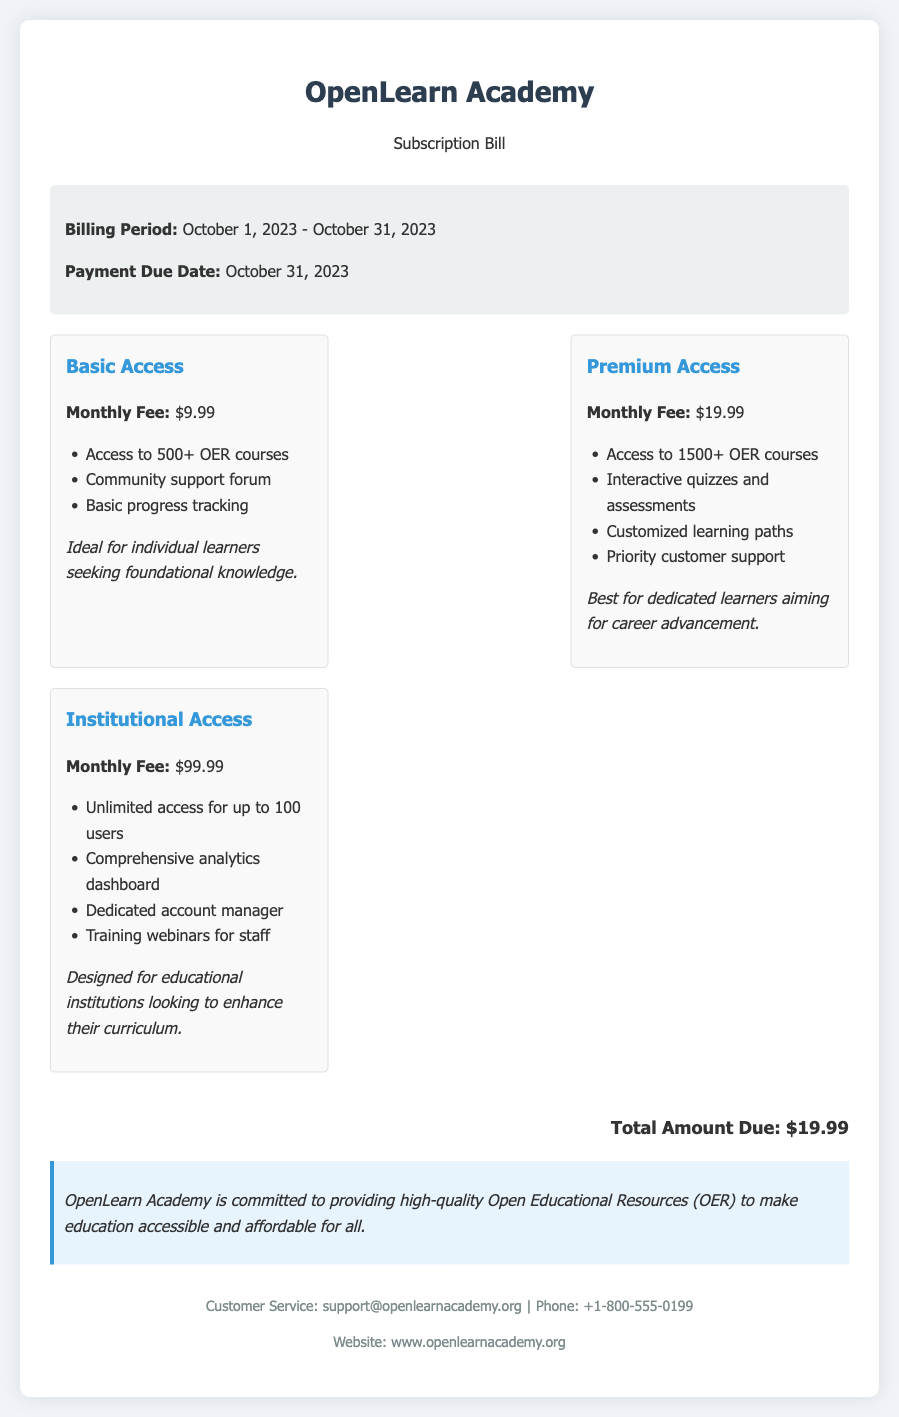What is the monthly fee for Basic Access? The monthly fee for Basic Access is stated in the document as $9.99.
Answer: $9.99 What is the total amount due for the current billing period? The total amount due is clearly mentioned in the document as $19.99.
Answer: $19.99 How many OER courses are available with Premium Access? The number of OER courses available with Premium Access is specified as 1500+.
Answer: 1500+ What is the billing period mentioned in the document? The billing period is identified as October 1, 2023 - October 31, 2023.
Answer: October 1, 2023 - October 31, 2023 Which subscription tier includes a dedicated account manager? The subscription tier that includes a dedicated account manager is Institutional Access.
Answer: Institutional Access How many users can access the Institutional Access tier? The document specifies that the Institutional Access tier allows unlimited access for up to 100 users.
Answer: 100 users What type of support is offered in Basic Access? Basic Access includes community support forum as part of its offerings.
Answer: Community support forum What is the purpose of the OER note at the bottom of the document? The OER note emphasizes OpenLearn Academy's commitment to making education accessible and affordable through OER.
Answer: Making education accessible and affordable What is the payment due date for this billing cycle? The payment due date is clearly mentioned as October 31, 2023.
Answer: October 31, 2023 